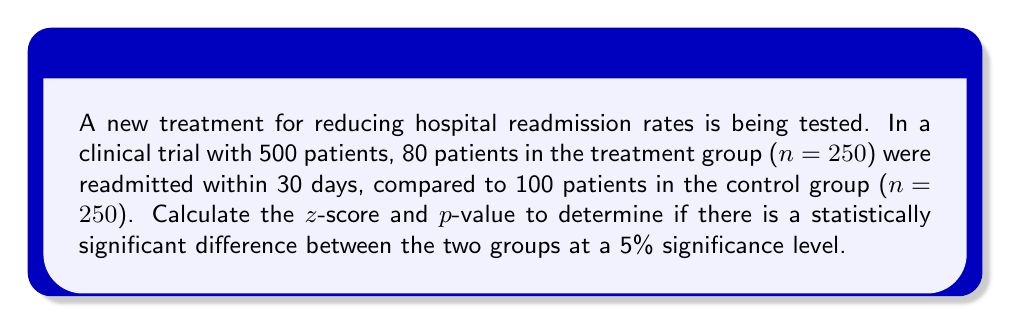Can you answer this question? To determine statistical significance, we'll use a two-proportion z-test.

Step 1: Calculate the proportions for each group
Treatment group: $p_1 = 80/250 = 0.32$
Control group: $p_2 = 100/250 = 0.40$

Step 2: Calculate the pooled proportion
$$p = \frac{80 + 100}{500} = 0.36$$

Step 3: Calculate the standard error
$$SE = \sqrt{p(1-p)(\frac{1}{n_1} + \frac{1}{n_2})} = \sqrt{0.36(0.64)(\frac{1}{250} + \frac{1}{250})} = 0.0428$$

Step 4: Calculate the z-score
$$z = \frac{p_1 - p_2}{SE} = \frac{0.32 - 0.40}{0.0428} = -1.87$$

Step 5: Calculate the p-value (two-tailed test)
Using a standard normal distribution table or calculator:
p-value = $2 * P(Z < -1.87) = 2 * 0.0307 = 0.0614$

Step 6: Compare p-value to significance level
0.0614 > 0.05, so we fail to reject the null hypothesis at the 5% significance level.
Answer: z-score = -1.87, p-value = 0.0614. Not statistically significant at 5% level. 